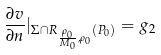Convert formula to latex. <formula><loc_0><loc_0><loc_500><loc_500>\frac { \partial v } { \partial n } | _ { \Sigma \cap R _ { \frac { \rho _ { 0 } } { M _ { 0 } } , \rho _ { 0 } } ( P _ { 0 } ) } = g _ { 2 }</formula> 